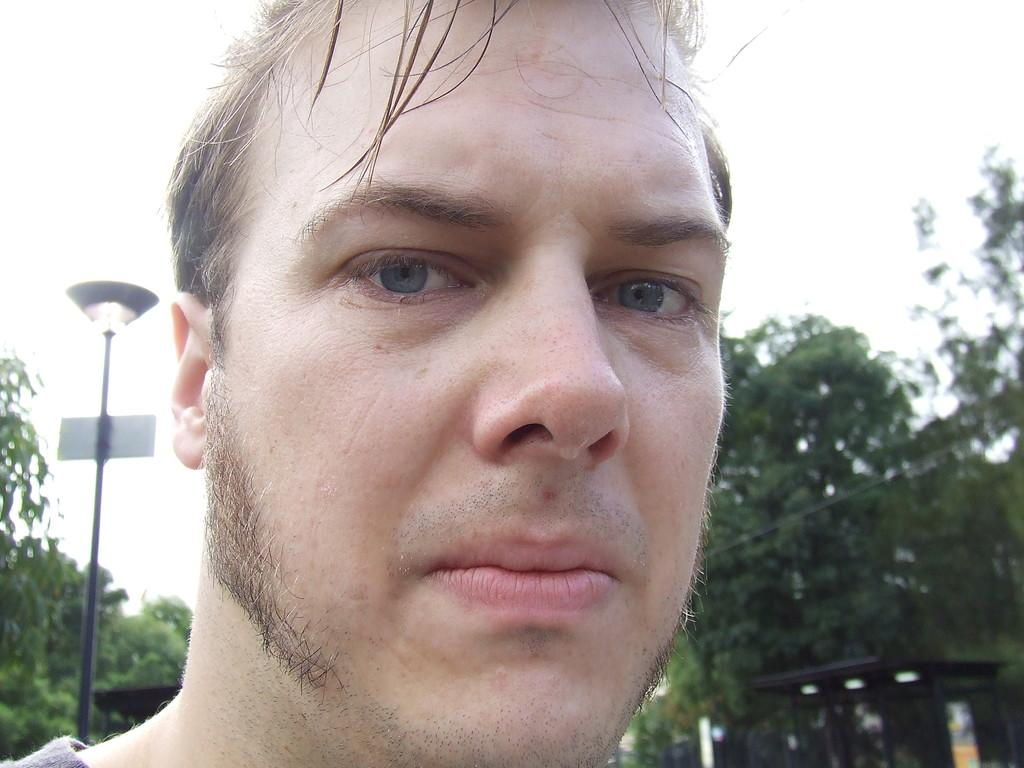What is the main subject of the image? There is a face of a man in the image. What can be seen in the background of the image? There are trees in the background of the image. What object is on the left side of the image? There is a pole with a light on the left side of the image. How does the man in the image feel about his debt? There is no indication of debt or any emotions in the image, as it only features the face of a man and a pole with a light. 